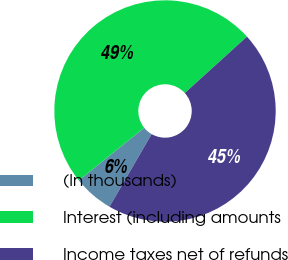Convert chart to OTSL. <chart><loc_0><loc_0><loc_500><loc_500><pie_chart><fcel>(In thousands)<fcel>Interest (including amounts<fcel>Income taxes net of refunds<nl><fcel>5.85%<fcel>49.06%<fcel>45.09%<nl></chart> 